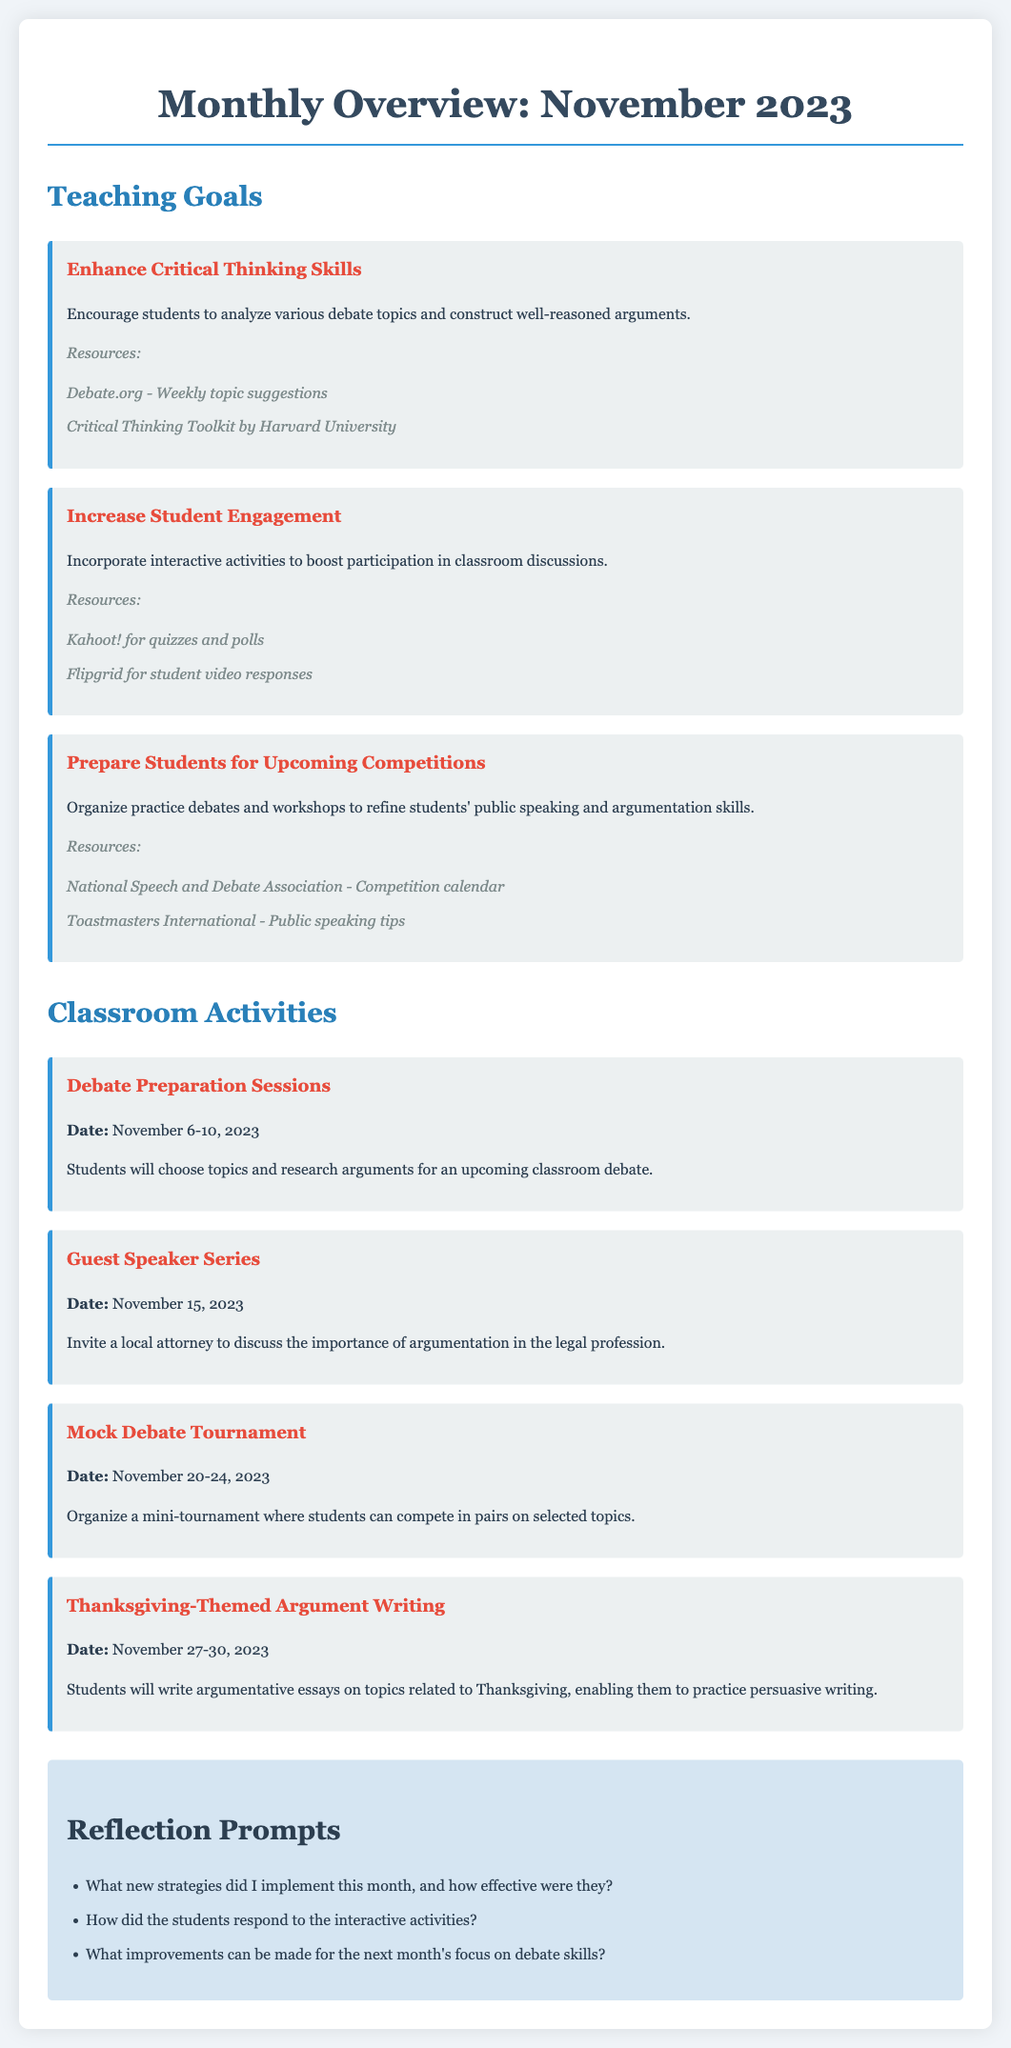What is the first teaching goal listed? The first teaching goal mentioned is to enhance critical thinking skills, which is focused on analyzing debate topics.
Answer: Enhance Critical Thinking Skills What activity is scheduled for November 15, 2023? The document specifies a guest speaker series with a local attorney discussing argumentation in the legal profession on this date.
Answer: Guest Speaker Series How many teaching goals are listed in total? The document outlines three distinct teaching goals that the teacher aims to achieve during this month.
Answer: 3 What is one resource mentioned for increasing student engagement? The teacher can use Kahoot! for quizzes and polls as a resource to enhance student engagement in the classroom.
Answer: Kahoot! When will the mock debate tournament take place? The dates for the mock debate tournament are indicated as November 20-24, 2023, in the calendar of activities.
Answer: November 20-24, 2023 What is the last classroom activity mentioned? The last activity listed is about Thanksgiving-themed argument writing, which focuses on persuasive essay writing related to Thanksgiving topics.
Answer: Thanksgiving-Themed Argument Writing How many reflection prompts are provided? The document includes a total of three reflection prompts for the teacher to consider after implementing the month's strategies.
Answer: 3 Which organization provides a resource for preparing students for competitions? The National Speech and Debate Association is mentioned as a resource for competition schedules in preparation workshops.
Answer: National Speech and Debate Association 